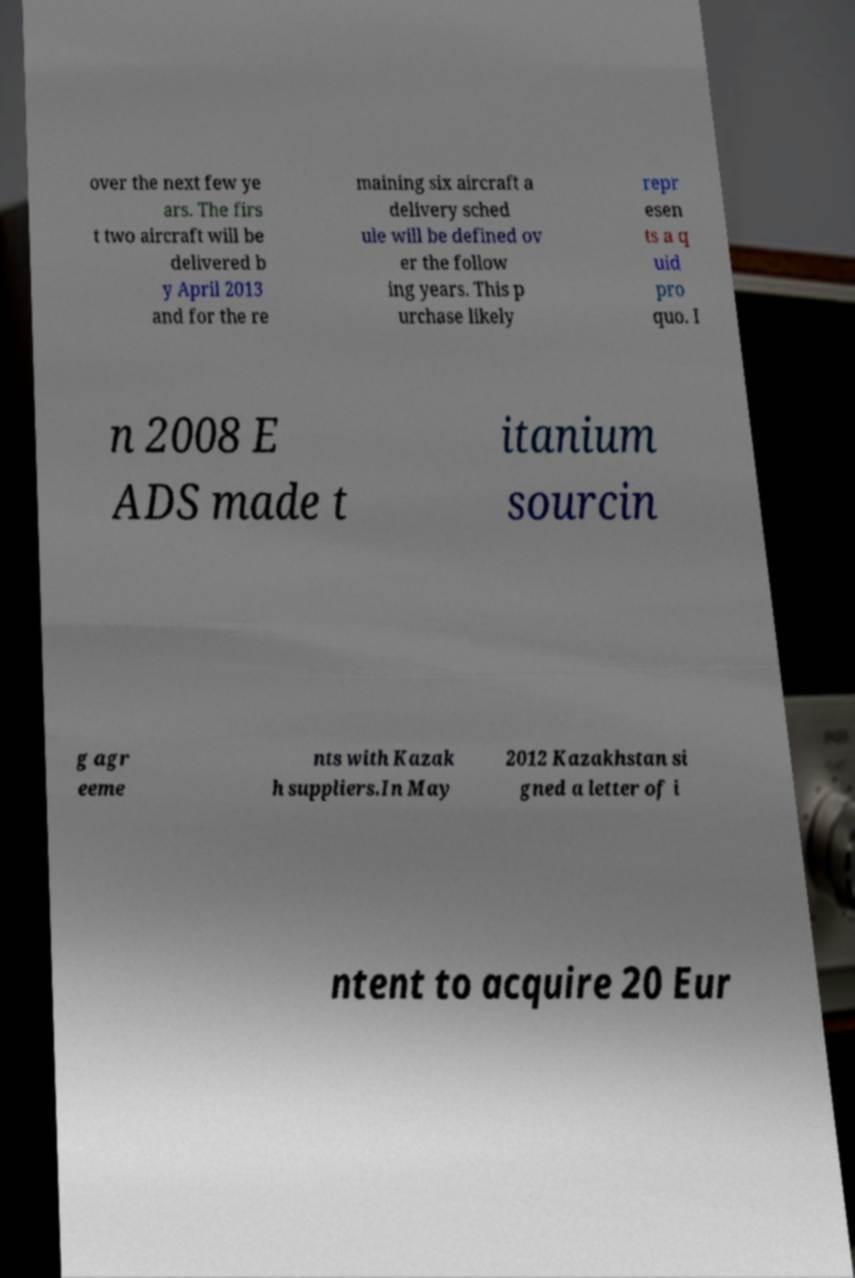Can you read and provide the text displayed in the image?This photo seems to have some interesting text. Can you extract and type it out for me? over the next few ye ars. The firs t two aircraft will be delivered b y April 2013 and for the re maining six aircraft a delivery sched ule will be defined ov er the follow ing years. This p urchase likely repr esen ts a q uid pro quo. I n 2008 E ADS made t itanium sourcin g agr eeme nts with Kazak h suppliers.In May 2012 Kazakhstan si gned a letter of i ntent to acquire 20 Eur 